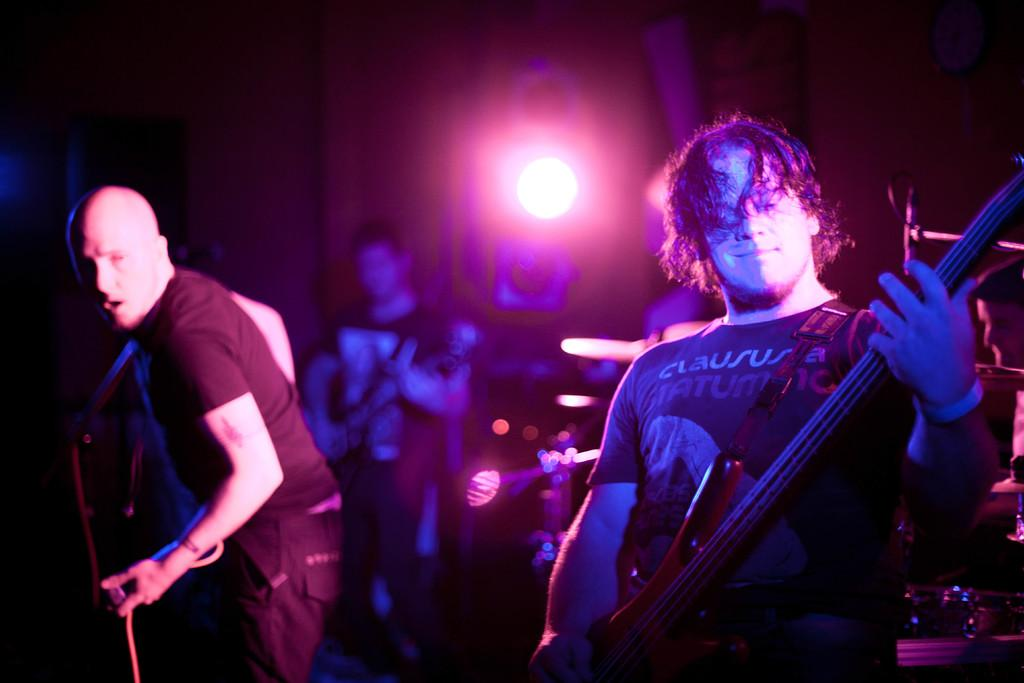What can be seen in the image that provides light? There is a light in the image. How many people are present in the image? There are three people in the image. What are the people doing in the image? The people are standing and holding guitars in their hands. What type of juice is being squeezed from the stone in the image? There is no stone or juice present in the image; it features a light and three people holding guitars. 